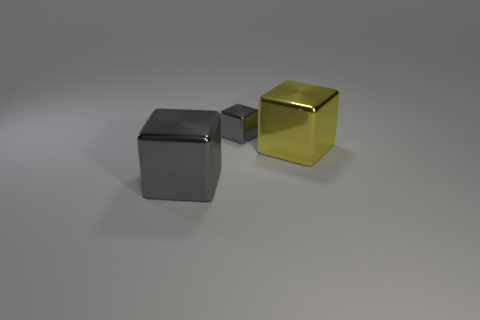Subtract all gray cubes. How many were subtracted if there are1gray cubes left? 1 Add 2 balls. How many objects exist? 5 Subtract all yellow metal blocks. How many blocks are left? 2 Subtract all gray blocks. How many blocks are left? 1 Subtract 1 blocks. How many blocks are left? 2 Subtract all brown cubes. Subtract all yellow cylinders. How many cubes are left? 3 Subtract all gray balls. How many gray blocks are left? 2 Subtract all big gray things. Subtract all gray metal things. How many objects are left? 0 Add 3 large yellow cubes. How many large yellow cubes are left? 4 Add 2 big things. How many big things exist? 4 